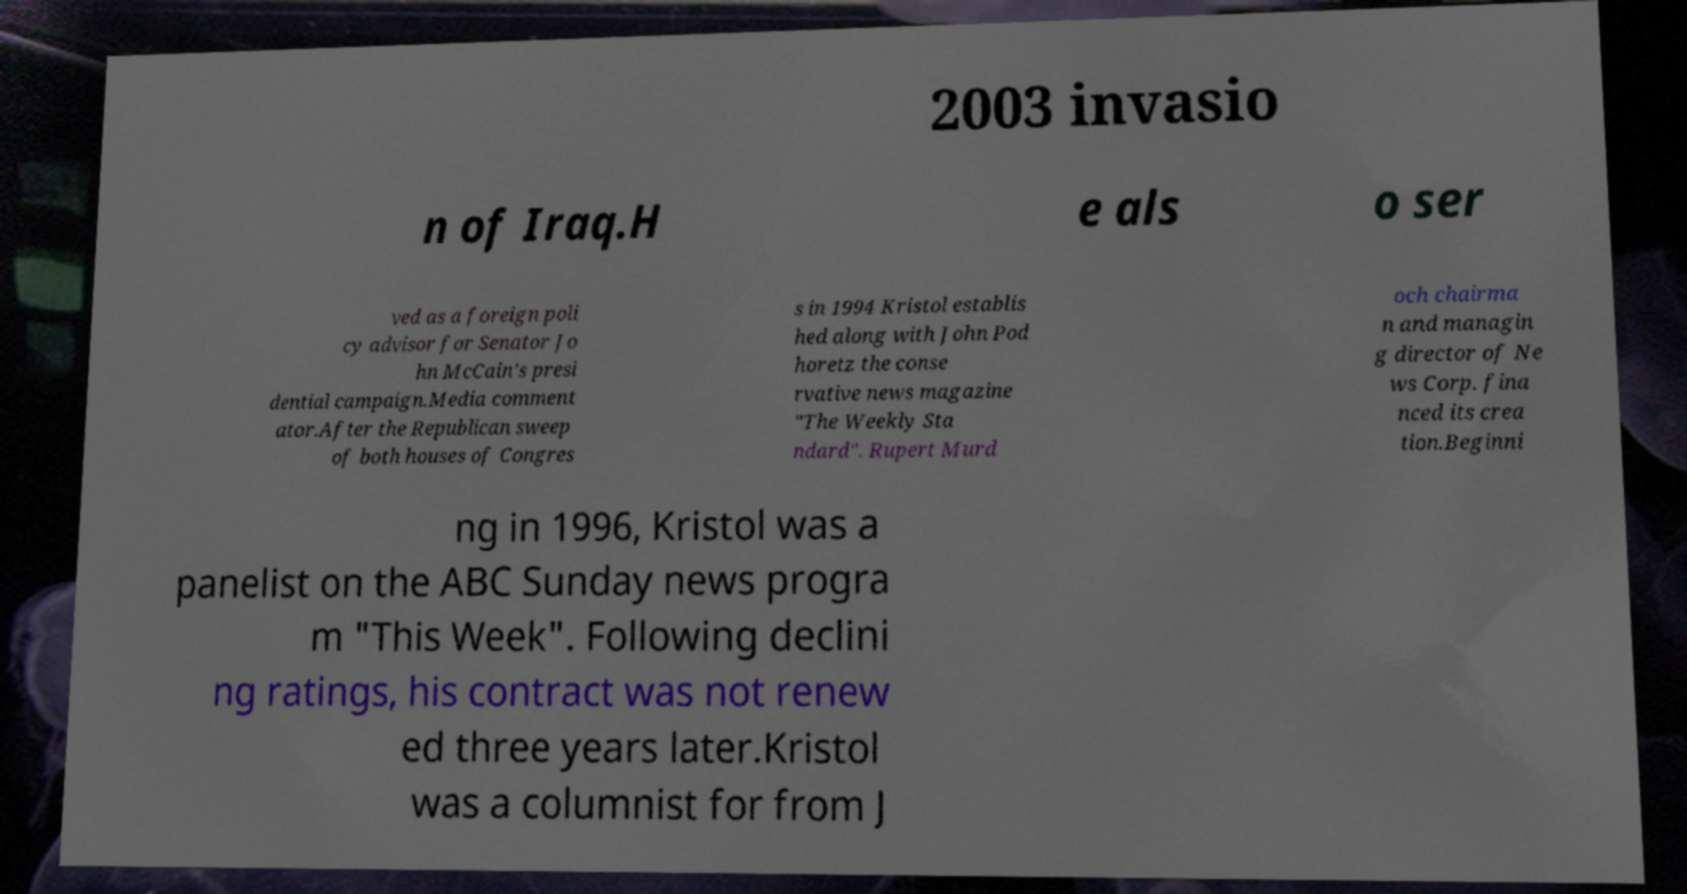Please identify and transcribe the text found in this image. 2003 invasio n of Iraq.H e als o ser ved as a foreign poli cy advisor for Senator Jo hn McCain's presi dential campaign.Media comment ator.After the Republican sweep of both houses of Congres s in 1994 Kristol establis hed along with John Pod horetz the conse rvative news magazine "The Weekly Sta ndard". Rupert Murd och chairma n and managin g director of Ne ws Corp. fina nced its crea tion.Beginni ng in 1996, Kristol was a panelist on the ABC Sunday news progra m "This Week". Following declini ng ratings, his contract was not renew ed three years later.Kristol was a columnist for from J 